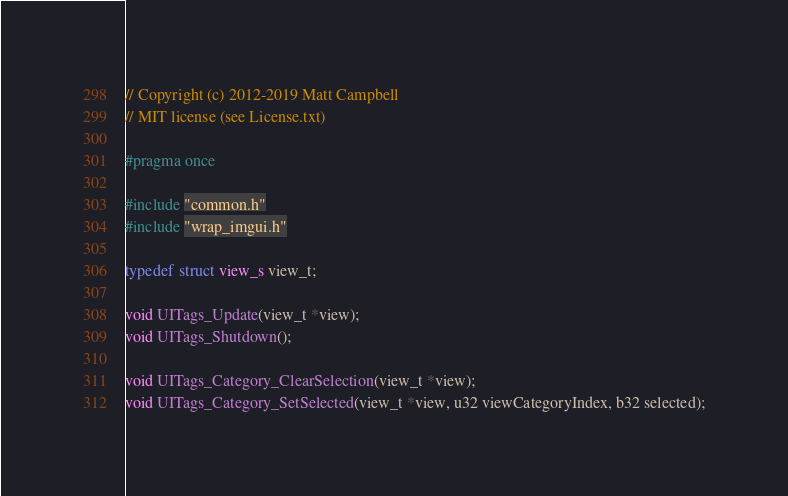<code> <loc_0><loc_0><loc_500><loc_500><_C_>// Copyright (c) 2012-2019 Matt Campbell
// MIT license (see License.txt)

#pragma once

#include "common.h"
#include "wrap_imgui.h"

typedef struct view_s view_t;

void UITags_Update(view_t *view);
void UITags_Shutdown();

void UITags_Category_ClearSelection(view_t *view);
void UITags_Category_SetSelected(view_t *view, u32 viewCategoryIndex, b32 selected);
</code> 